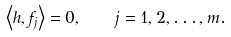Convert formula to latex. <formula><loc_0><loc_0><loc_500><loc_500>\left \langle h , f _ { j } \right \rangle = 0 , \quad j = 1 , 2 , \dots , m .</formula> 